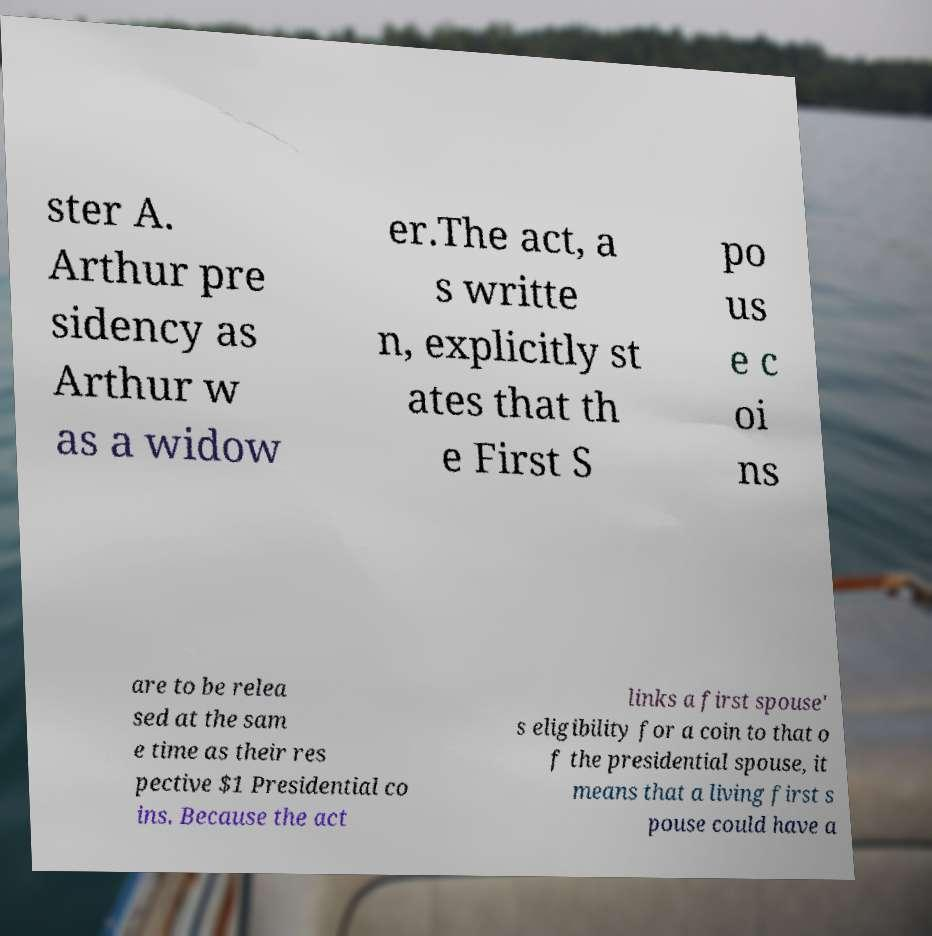Please read and relay the text visible in this image. What does it say? ster A. Arthur pre sidency as Arthur w as a widow er.The act, a s writte n, explicitly st ates that th e First S po us e c oi ns are to be relea sed at the sam e time as their res pective $1 Presidential co ins. Because the act links a first spouse' s eligibility for a coin to that o f the presidential spouse, it means that a living first s pouse could have a 